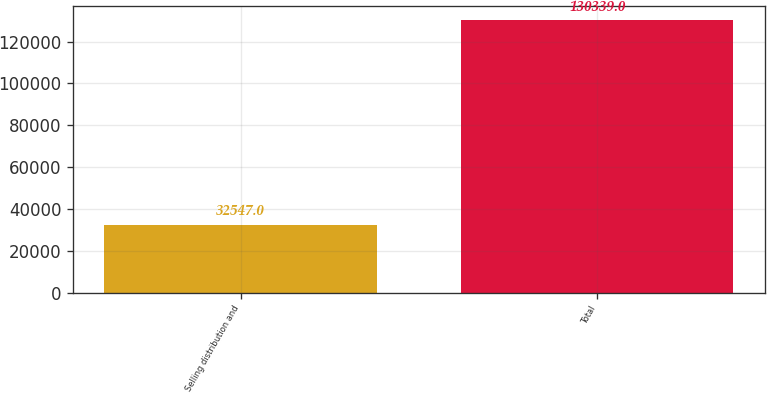Convert chart. <chart><loc_0><loc_0><loc_500><loc_500><bar_chart><fcel>Selling distribution and<fcel>Total<nl><fcel>32547<fcel>130339<nl></chart> 